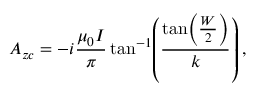Convert formula to latex. <formula><loc_0><loc_0><loc_500><loc_500>A _ { z c } = - i \frac { \mu _ { 0 } I } { \pi } \tan ^ { - 1 } \, \left ( \frac { \tan \, \left ( \frac { W } { 2 } \right ) } { k } \right ) ,</formula> 